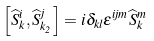<formula> <loc_0><loc_0><loc_500><loc_500>\left [ \widehat { S } _ { k } ^ { i } , \widehat { S } _ { k _ { 2 } } ^ { j } \right ] = i \delta _ { k l } \epsilon ^ { i j m } \widehat { S } _ { k } ^ { m }</formula> 